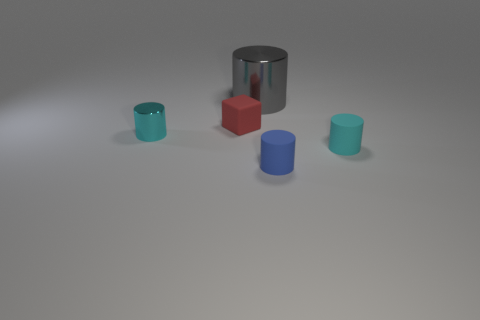Subtract all cyan metallic cylinders. How many cylinders are left? 3 Add 4 tiny gray metal balls. How many objects exist? 9 Subtract all gray cylinders. How many cylinders are left? 3 Subtract all green cylinders. Subtract all green cubes. How many cylinders are left? 4 Subtract all cyan blocks. How many gray cylinders are left? 1 Subtract all small cyan metal things. Subtract all rubber blocks. How many objects are left? 3 Add 2 shiny things. How many shiny things are left? 4 Add 5 tiny cyan things. How many tiny cyan things exist? 7 Subtract 1 blue cylinders. How many objects are left? 4 Subtract all cylinders. How many objects are left? 1 